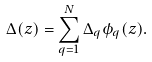Convert formula to latex. <formula><loc_0><loc_0><loc_500><loc_500>\Delta ( z ) = \sum _ { q = 1 } ^ { N } \Delta _ { q } \phi _ { q } ( z ) .</formula> 